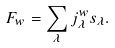Convert formula to latex. <formula><loc_0><loc_0><loc_500><loc_500>F _ { w } = \sum _ { \lambda } j _ { \lambda } ^ { w } s _ { \lambda } .</formula> 